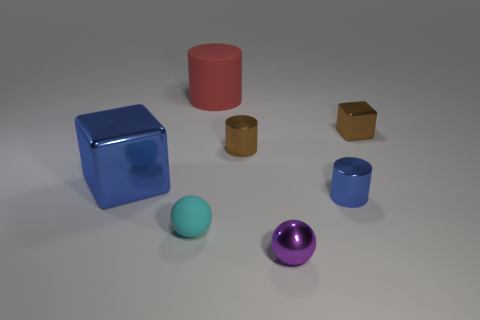Can you describe the overall scene depicted in this image? The image presents a collection of geometric shapes with various colors and materials arranged on a flat surface. Objects include a large blue metallic cube, a medium-sized red cylinder, two small gold-toned cubes, a small blue mug, a teal sphere, and a purple metallic sphere. The arrangement is spread out with no apparent pattern, suggesting a display or a study of shapes and materials. 